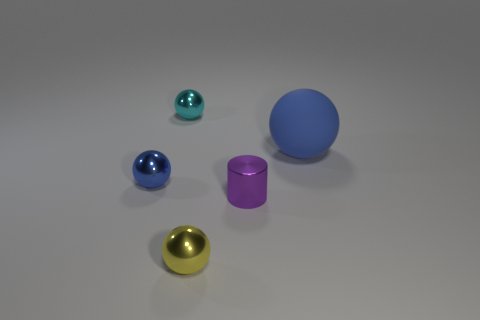Subtract all brown spheres. Subtract all purple cubes. How many spheres are left? 4 Add 2 purple metallic things. How many objects exist? 7 Subtract all cylinders. How many objects are left? 4 Subtract 0 gray cylinders. How many objects are left? 5 Subtract all cyan shiny objects. Subtract all purple objects. How many objects are left? 3 Add 3 small things. How many small things are left? 7 Add 3 yellow metal spheres. How many yellow metal spheres exist? 4 